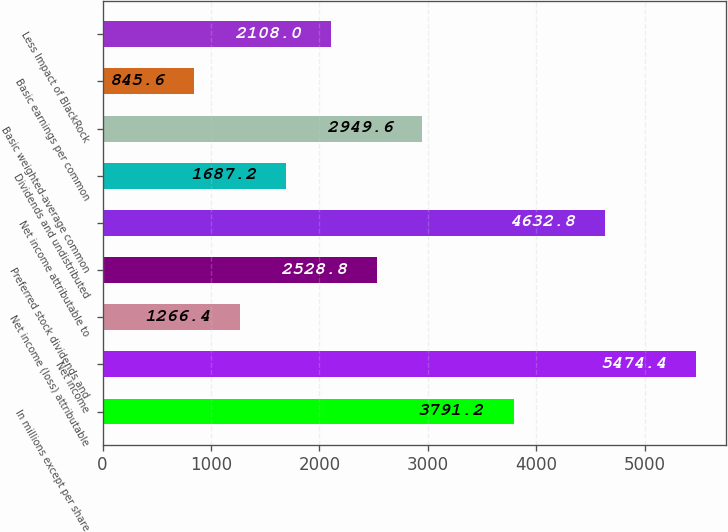Convert chart. <chart><loc_0><loc_0><loc_500><loc_500><bar_chart><fcel>In millions except per share<fcel>Net income<fcel>Net income (loss) attributable<fcel>Preferred stock dividends and<fcel>Net income attributable to<fcel>Dividends and undistributed<fcel>Basic weighted-average common<fcel>Basic earnings per common<fcel>Less Impact of BlackRock<nl><fcel>3791.2<fcel>5474.4<fcel>1266.4<fcel>2528.8<fcel>4632.8<fcel>1687.2<fcel>2949.6<fcel>845.6<fcel>2108<nl></chart> 